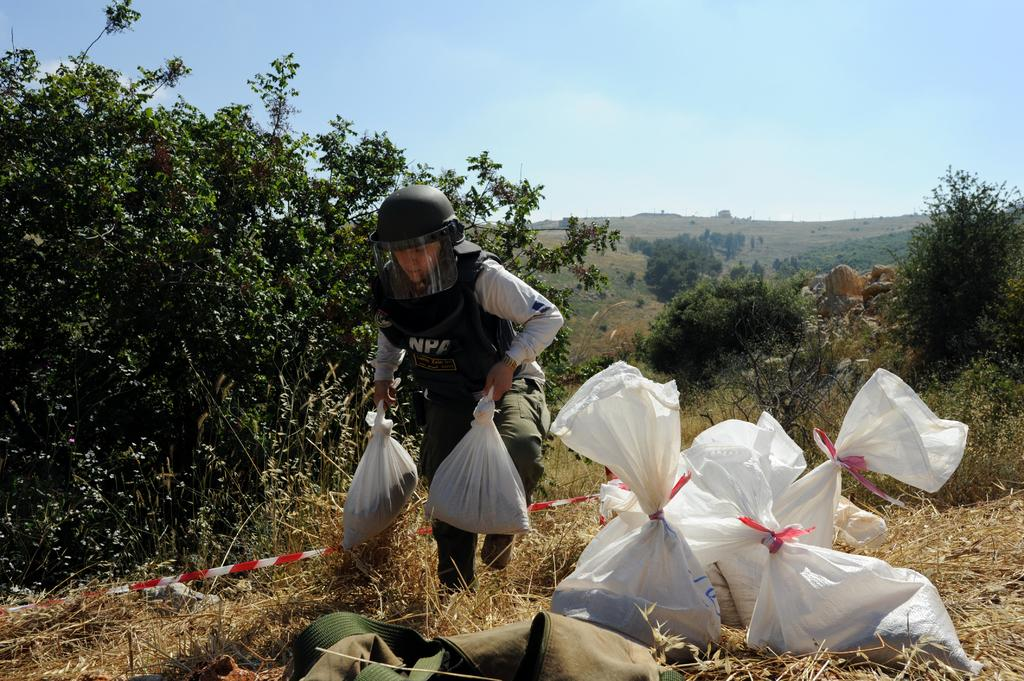What is the person in the image wearing on their head? The person in the image is wearing a helmet. What is the person holding in their hands? The person is holding plastic bags. Are there any plastic bags visible in the image besides the ones the person is holding? Yes, there are plastic bags visible in the image. What can be seen in the background of the image? There are trees in the background of the image. What letter can be seen on the seashore in the image? There is no seashore or letter present in the image. 